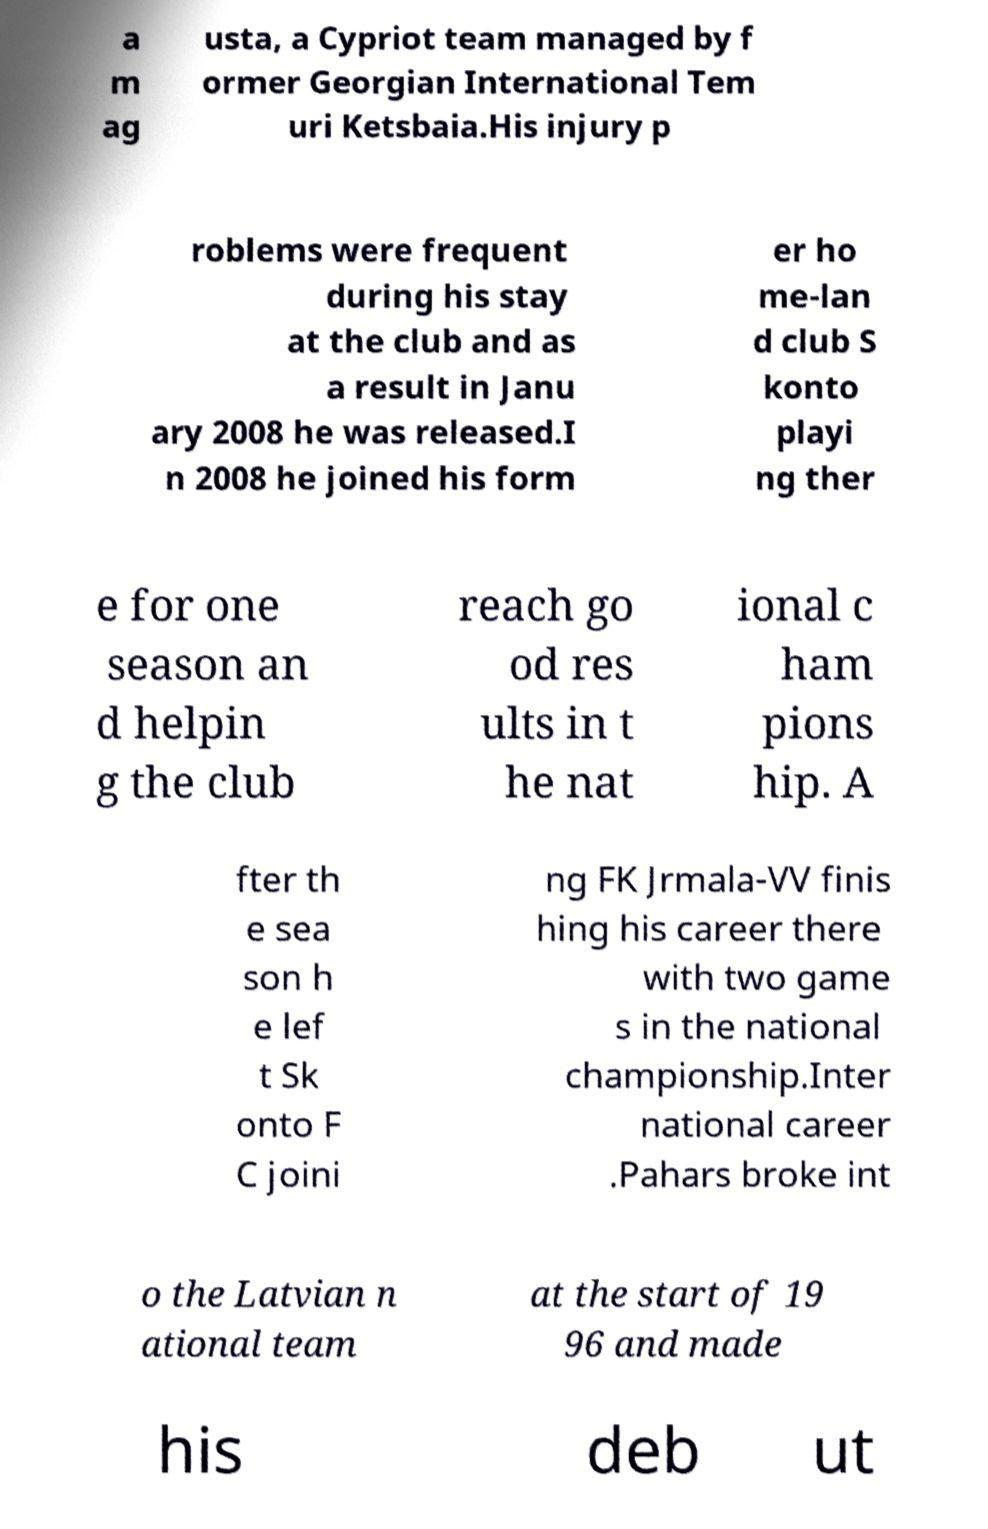Please identify and transcribe the text found in this image. a m ag usta, a Cypriot team managed by f ormer Georgian International Tem uri Ketsbaia.His injury p roblems were frequent during his stay at the club and as a result in Janu ary 2008 he was released.I n 2008 he joined his form er ho me-lan d club S konto playi ng ther e for one season an d helpin g the club reach go od res ults in t he nat ional c ham pions hip. A fter th e sea son h e lef t Sk onto F C joini ng FK Jrmala-VV finis hing his career there with two game s in the national championship.Inter national career .Pahars broke int o the Latvian n ational team at the start of 19 96 and made his deb ut 